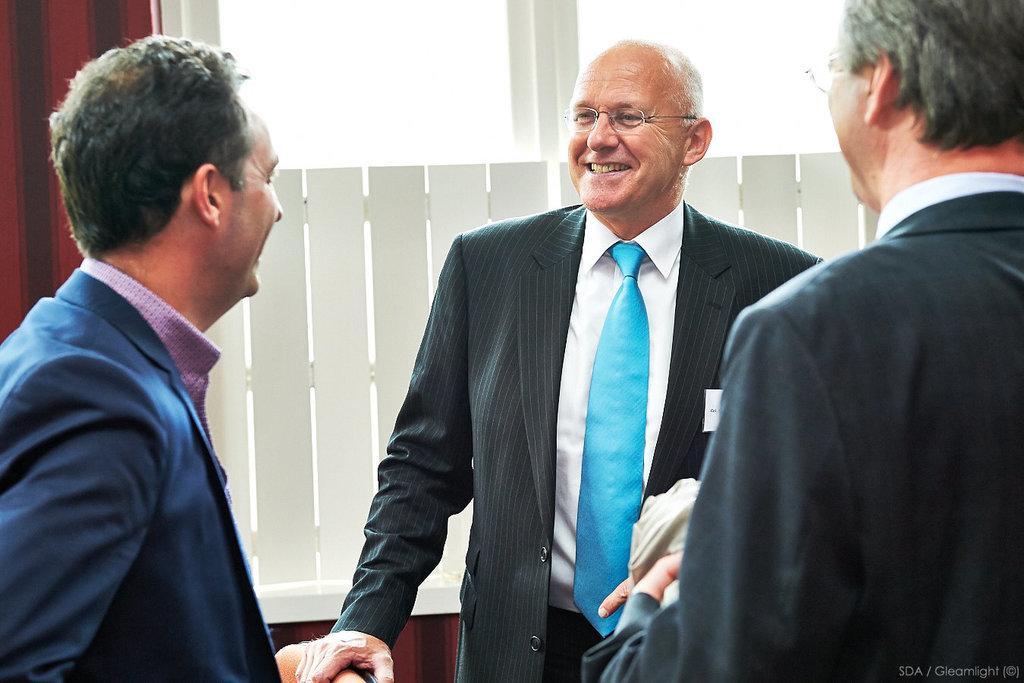Could you give a brief overview of what you see in this image? In this image, we can see people standing and smiling and in the background, there is a fence and there is a wall. 